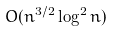Convert formula to latex. <formula><loc_0><loc_0><loc_500><loc_500>O ( n ^ { 3 / 2 } \log ^ { 2 } n )</formula> 